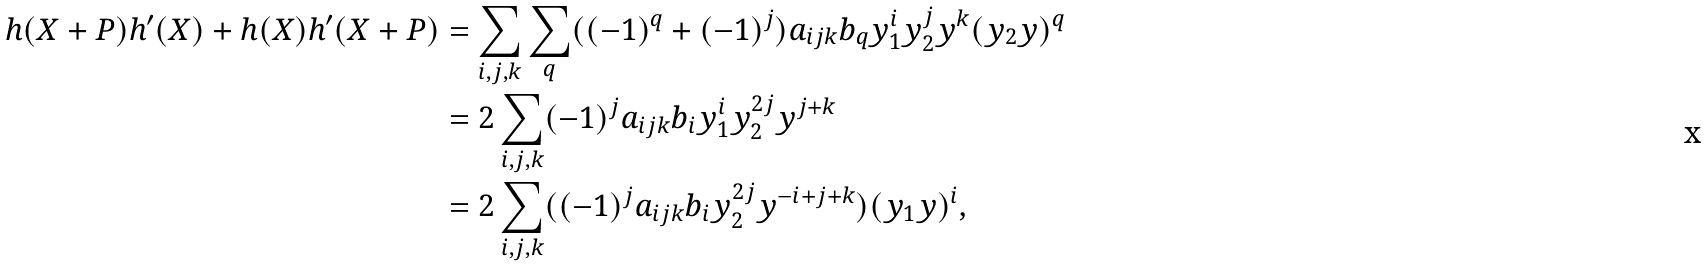Convert formula to latex. <formula><loc_0><loc_0><loc_500><loc_500>h ( X + P ) h ^ { \prime } ( X ) + h ( X ) h ^ { \prime } ( X + P ) & = \sum _ { i , j , k } \sum _ { q } ( ( - 1 ) ^ { q } + ( - 1 ) ^ { j } ) a _ { i j k } b _ { q } y _ { 1 } ^ { i } y _ { 2 } ^ { j } y ^ { k } ( y _ { 2 } y ) ^ { q } \\ & = 2 \sum _ { i , j , k } ( - 1 ) ^ { j } a _ { i j k } b _ { i } y _ { 1 } ^ { i } y _ { 2 } ^ { 2 j } y ^ { j + k } \\ & = 2 \sum _ { i , j , k } ( ( - 1 ) ^ { j } a _ { i j k } b _ { i } y _ { 2 } ^ { 2 j } y ^ { - i + j + k } ) ( y _ { 1 } y ) ^ { i } ,</formula> 